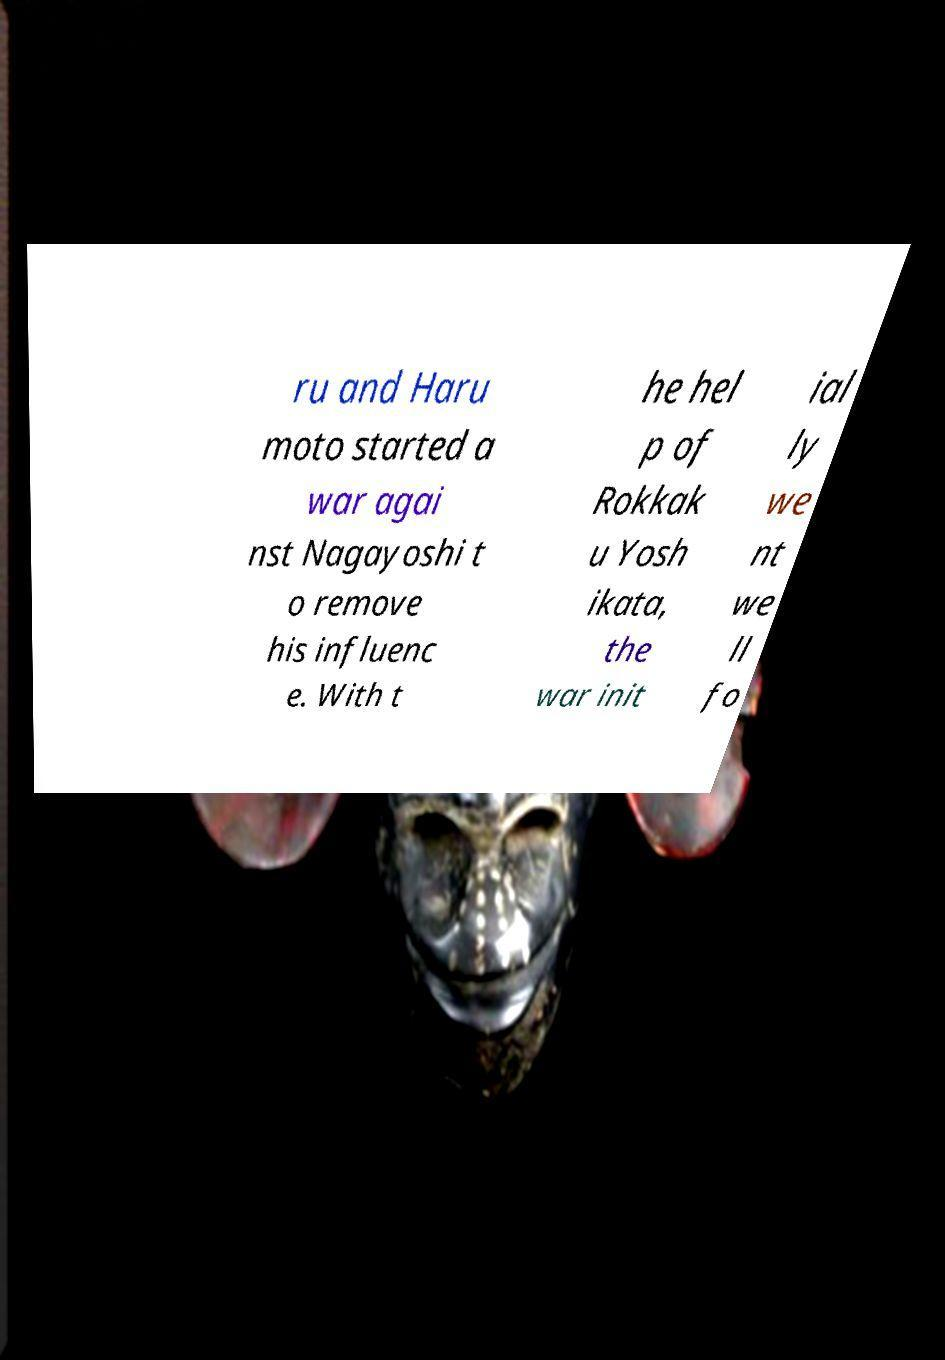Please identify and transcribe the text found in this image. ru and Haru moto started a war agai nst Nagayoshi t o remove his influenc e. With t he hel p of Rokkak u Yosh ikata, the war init ial ly we nt we ll fo 